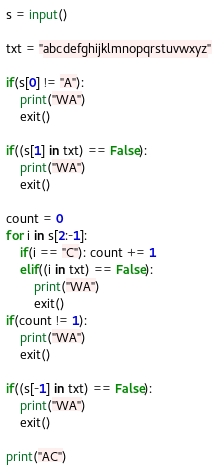Convert code to text. <code><loc_0><loc_0><loc_500><loc_500><_Python_>s = input()

txt = "abcdefghijklmnopqrstuvwxyz"

if(s[0] != "A"):
    print("WA")
    exit()

if((s[1] in txt) == False):
    print("WA")
    exit()

count = 0
for i in s[2:-1]:
    if(i == "C"): count += 1
    elif((i in txt) == False):
        print("WA")
        exit()
if(count != 1):
    print("WA")
    exit()

if((s[-1] in txt) == False):
    print("WA")
    exit()

print("AC")</code> 